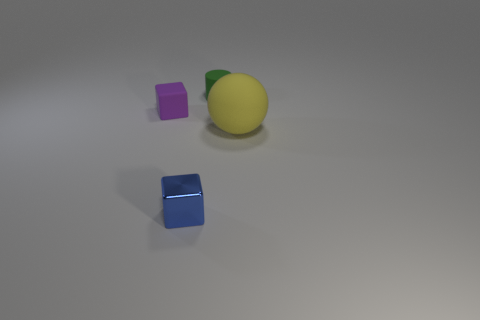Is there anything else that has the same size as the yellow object?
Keep it short and to the point. No. What color is the small block that is in front of the purple object?
Keep it short and to the point. Blue. There is a block in front of the sphere; is its size the same as the big yellow thing?
Offer a terse response. No. Is the number of tiny matte objects less than the number of metal blocks?
Your answer should be very brief. No. There is a tiny rubber cube; what number of small shiny objects are behind it?
Your answer should be compact. 0. Does the small blue object have the same shape as the purple object?
Your answer should be compact. Yes. How many objects are in front of the rubber sphere and to the right of the tiny green thing?
Give a very brief answer. 0. What number of things are either purple cubes or small cubes on the left side of the shiny thing?
Give a very brief answer. 1. Is the number of purple things greater than the number of blocks?
Your answer should be compact. No. There is a tiny thing that is in front of the matte sphere; what shape is it?
Provide a short and direct response. Cube. 